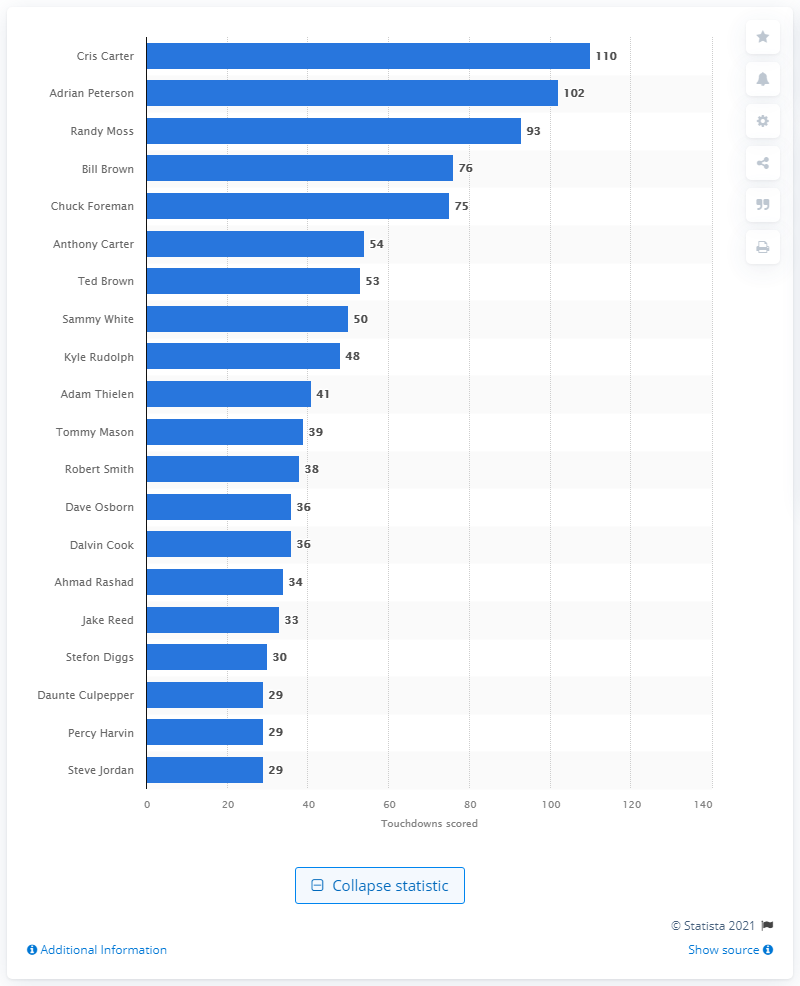Indicate a few pertinent items in this graphic. The career touchdown leader of the Minnesota Vikings is Cris Carter. 